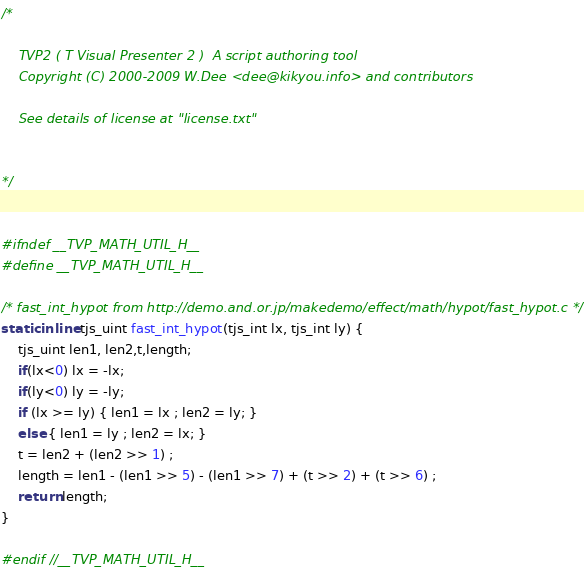<code> <loc_0><loc_0><loc_500><loc_500><_C_>/*

	TVP2 ( T Visual Presenter 2 )  A script authoring tool
	Copyright (C) 2000-2009 W.Dee <dee@kikyou.info> and contributors

	See details of license at "license.txt"


*/


#ifndef __TVP_MATH_UTIL_H__
#define __TVP_MATH_UTIL_H__

/* fast_int_hypot from http://demo.and.or.jp/makedemo/effect/math/hypot/fast_hypot.c */
static inline tjs_uint fast_int_hypot(tjs_int lx, tjs_int ly) {
	tjs_uint len1, len2,t,length;
	if(lx<0) lx = -lx;
	if(ly<0) ly = -ly;
	if (lx >= ly) { len1 = lx ; len2 = ly; }
	else { len1 = ly ; len2 = lx; }
	t = len2 + (len2 >> 1) ;
	length = len1 - (len1 >> 5) - (len1 >> 7) + (t >> 2) + (t >> 6) ;
	return length;
}

#endif //__TVP_MATH_UTIL_H__
</code> 